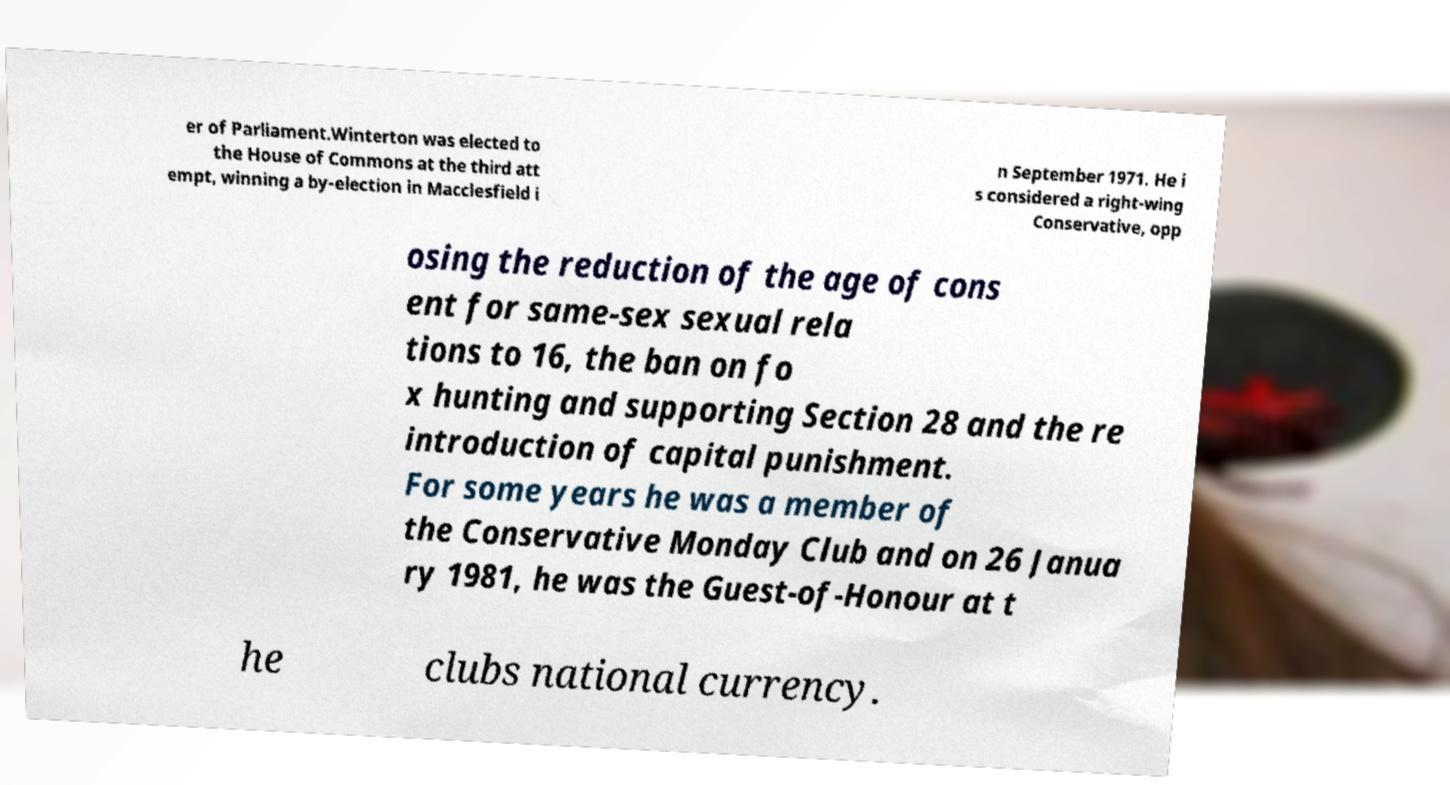What messages or text are displayed in this image? I need them in a readable, typed format. er of Parliament.Winterton was elected to the House of Commons at the third att empt, winning a by-election in Macclesfield i n September 1971. He i s considered a right-wing Conservative, opp osing the reduction of the age of cons ent for same-sex sexual rela tions to 16, the ban on fo x hunting and supporting Section 28 and the re introduction of capital punishment. For some years he was a member of the Conservative Monday Club and on 26 Janua ry 1981, he was the Guest-of-Honour at t he clubs national currency. 